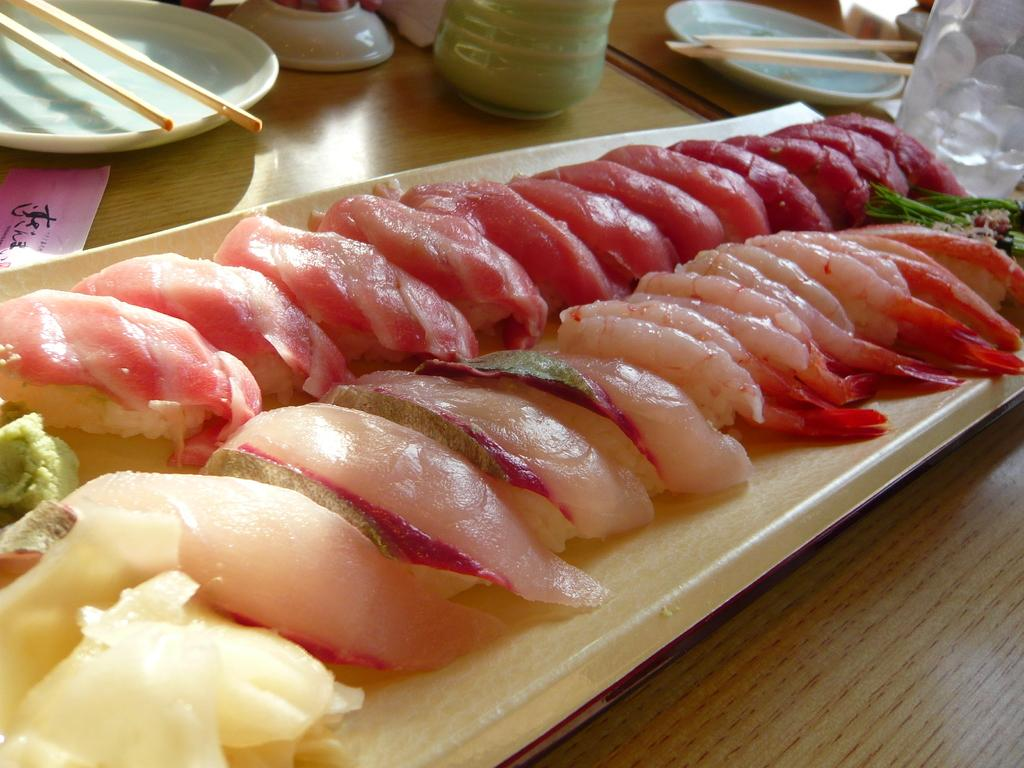What type of food can be seen in the image? There is food in the image, but the specific type is not mentioned. What objects are used for serving or eating the food? There are plates in the image, and chopsticks are present on the plates. What type of quartz is used as a decorative element in the image? There is no mention of quartz or any decorative elements in the image. The image only contains food, plates, and chopsticks. 